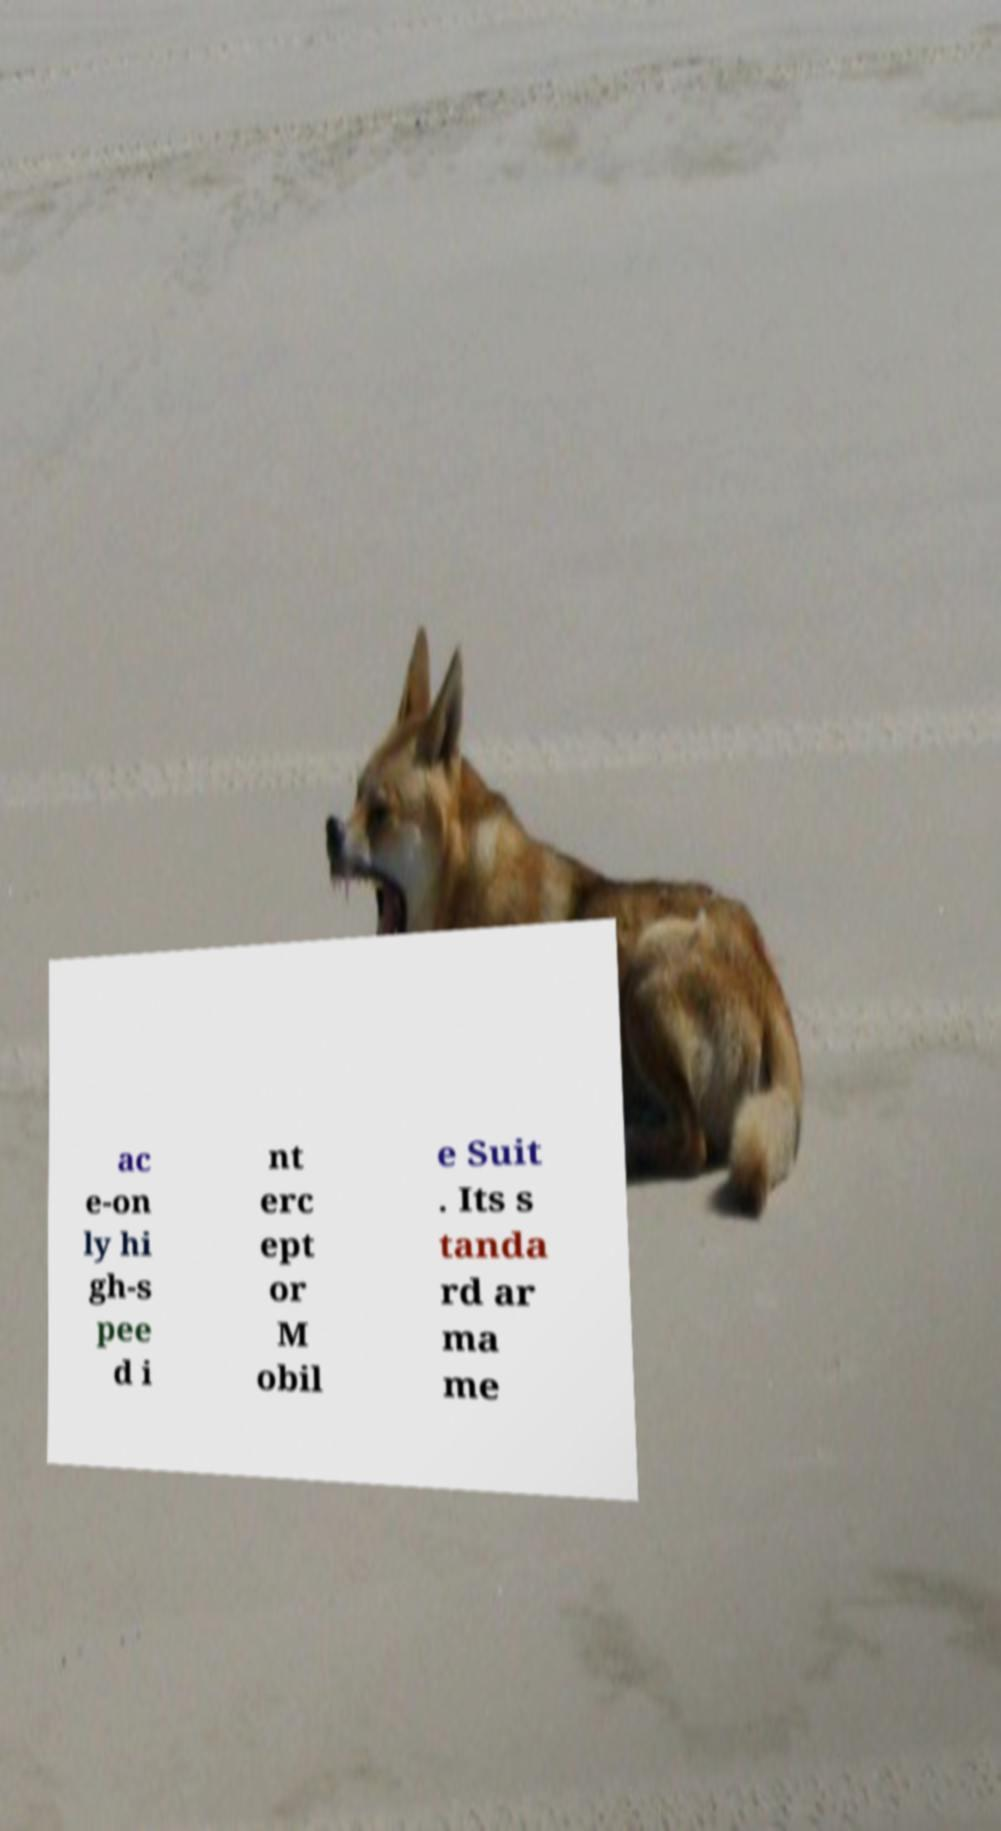Could you extract and type out the text from this image? ac e-on ly hi gh-s pee d i nt erc ept or M obil e Suit . Its s tanda rd ar ma me 